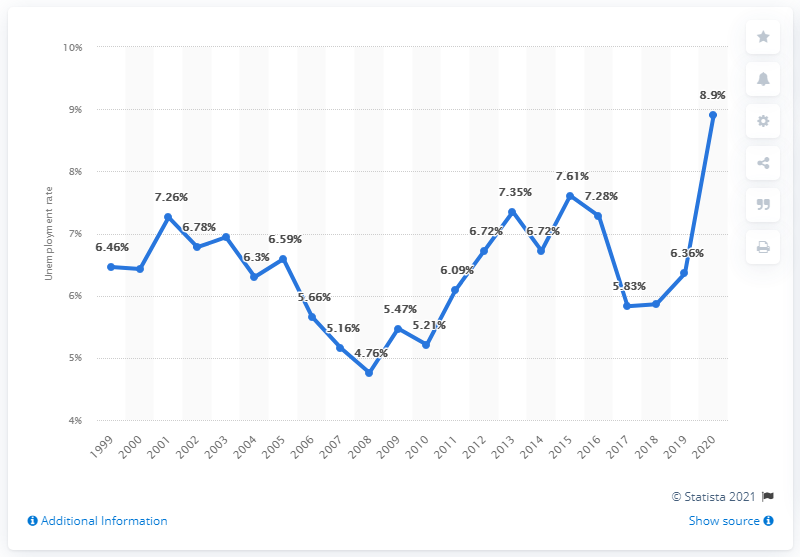Outline some significant characteristics in this image. In 2020, the unemployment rate in the Dominican Republic was 8.9%. 